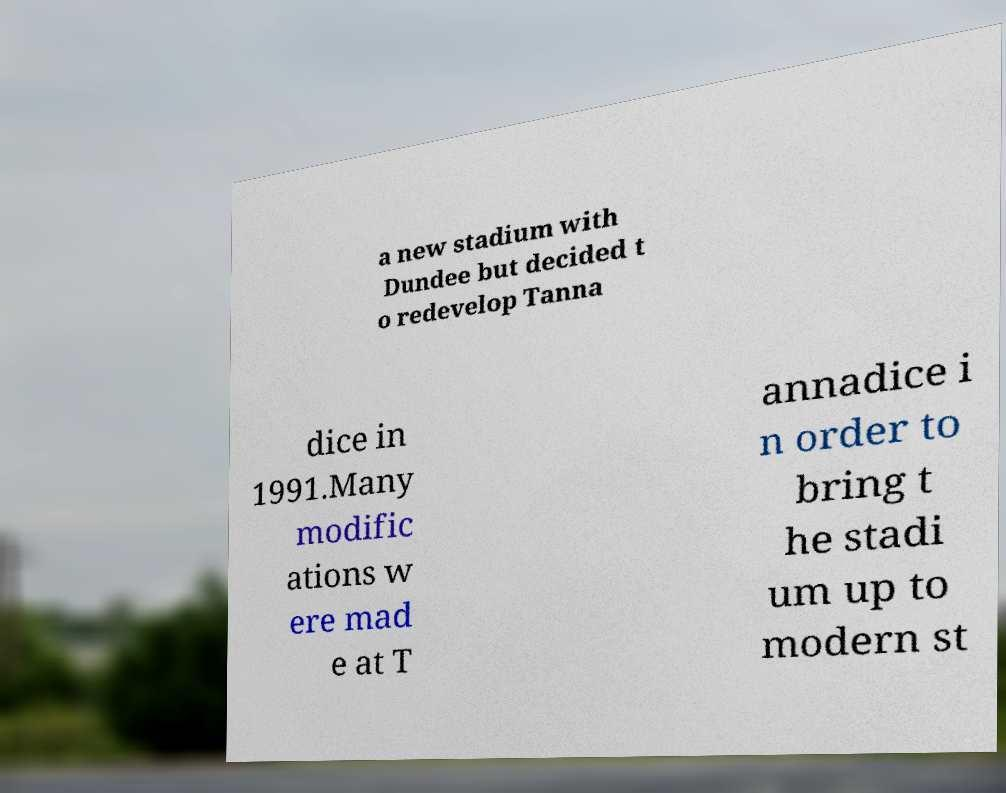For documentation purposes, I need the text within this image transcribed. Could you provide that? a new stadium with Dundee but decided t o redevelop Tanna dice in 1991.Many modific ations w ere mad e at T annadice i n order to bring t he stadi um up to modern st 